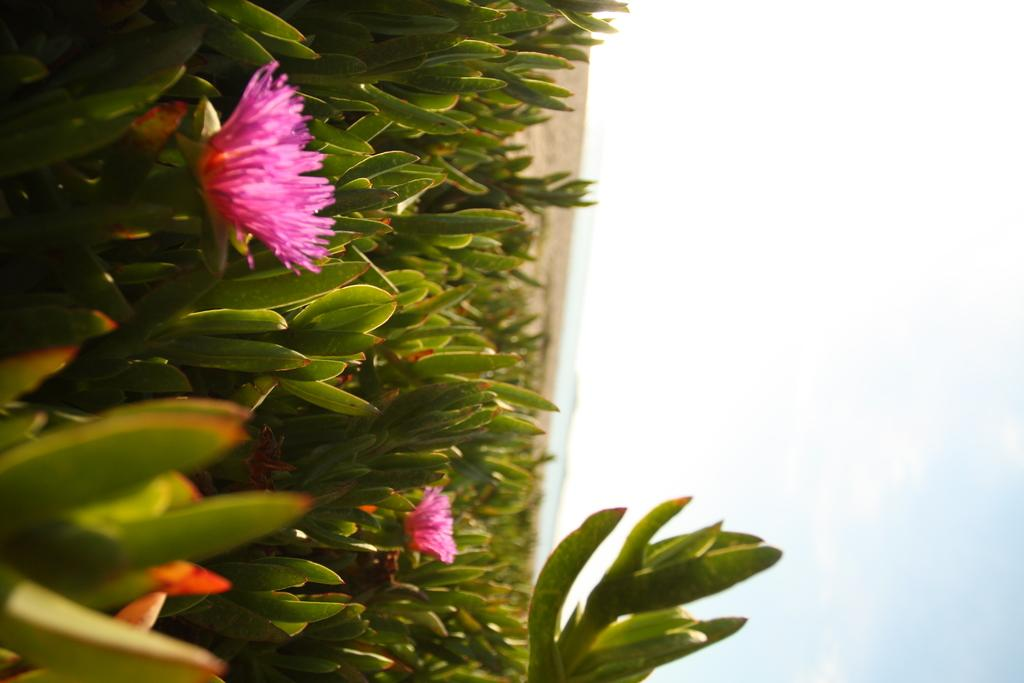What type of vegetation can be seen in the image? There are flowers and plants in the image. How is the image oriented? The image appears to be inverted. What natural elements are visible in the image? There is a sea and the sky visible in the image. How many people are touching the flowers in the image? There are no people present in the image, so no one can touch the flowers. What type of voyage is depicted in the image? There is no voyage depicted in the image; it features flowers, plants, an inverted orientation, a sea, and the sky. 